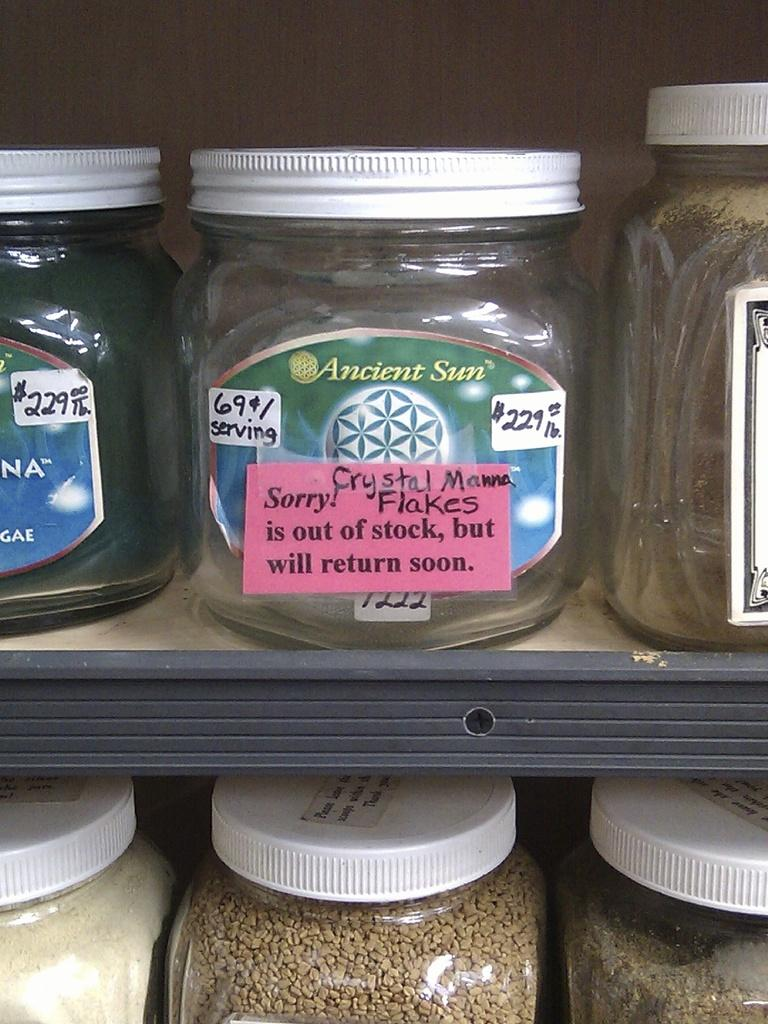<image>
Write a terse but informative summary of the picture. A empty container with a sign apologizing for being out of stock. 